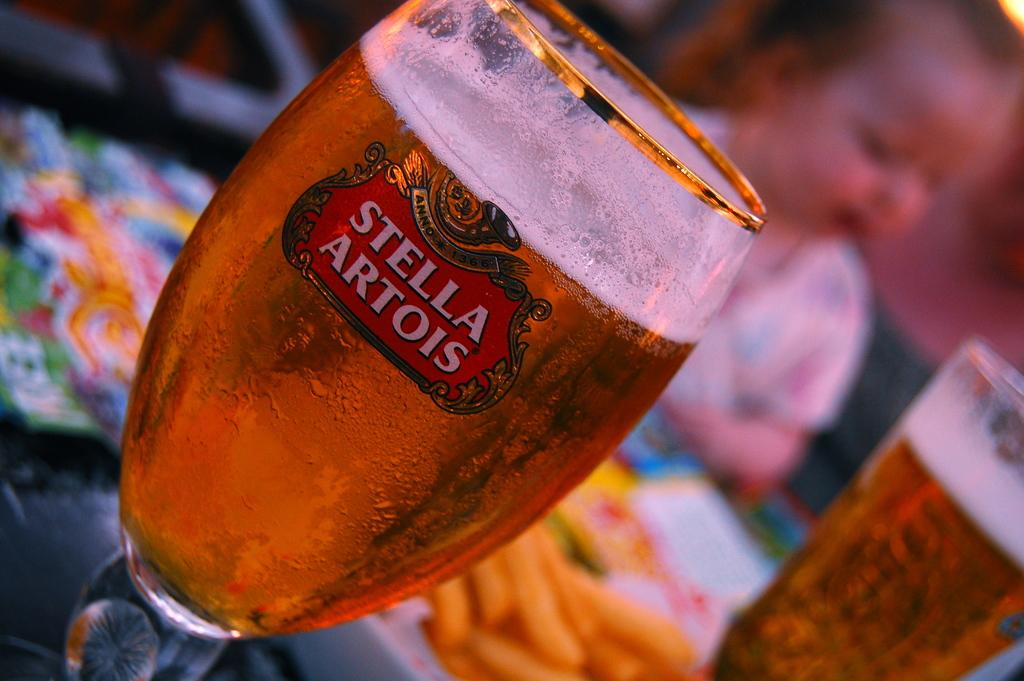What can be observed about the background of the picture? The background portion of the picture is blurry. What is the main subject of the picture? There is a kid in the picture. What else can be seen in the picture besides the kid? There are drinks in glasses in the picture. How would you describe the overall appearance of the picture? The remaining portion of the picture is blurry and colorful. What type of school can be seen in the picture? There is no school present in the picture. What kind of discovery is being made by the kid in the picture? The picture does not depict any specific discovery being made by the kid. 